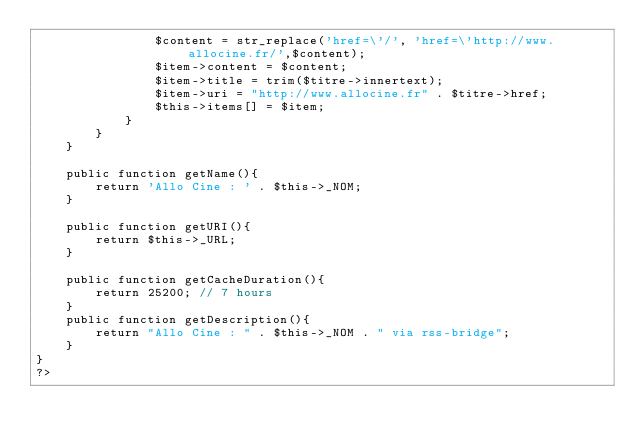<code> <loc_0><loc_0><loc_500><loc_500><_PHP_>                $content = str_replace('href=\'/', 'href=\'http://www.allocine.fr/',$content);
                $item->content = $content;
                $item->title = trim($titre->innertext);
                $item->uri = "http://www.allocine.fr" . $titre->href;
                $this->items[] = $item;
            }
        }
    }

    public function getName(){
        return 'Allo Cine : ' . $this->_NOM;
    }

    public function getURI(){
        return $this->_URL;
    }

    public function getCacheDuration(){
        return 25200; // 7 hours
    }
    public function getDescription(){
        return "Allo Cine : " . $this->_NOM . " via rss-bridge";
    }
}
?>
</code> 